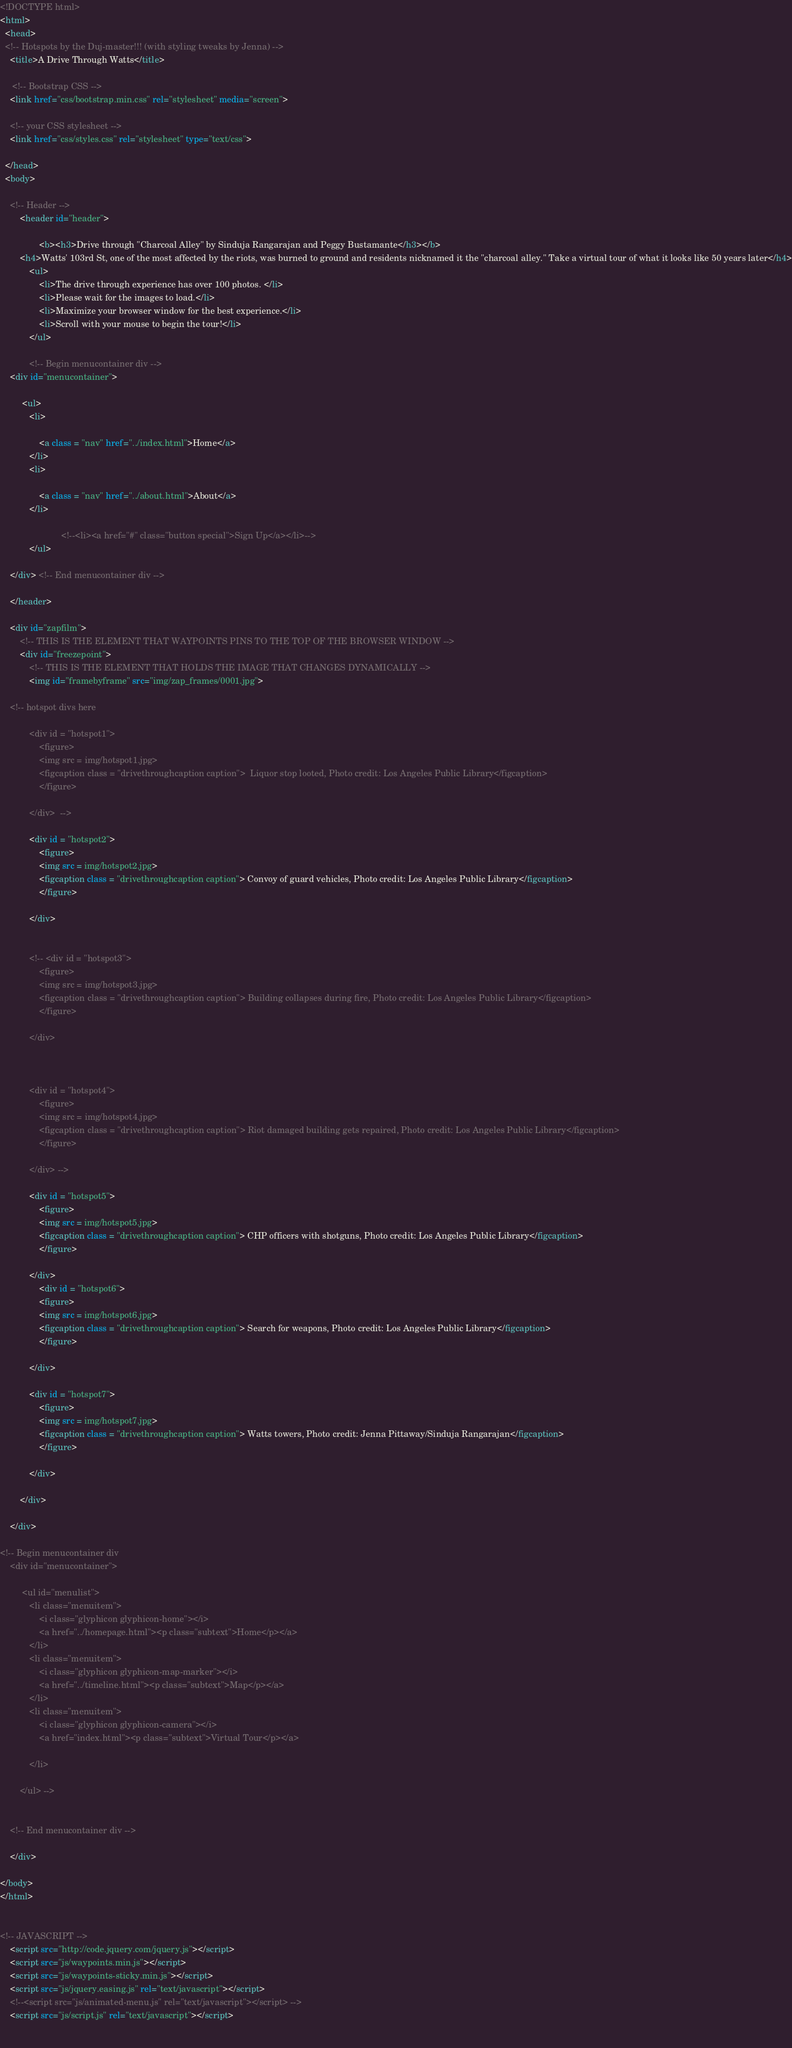<code> <loc_0><loc_0><loc_500><loc_500><_HTML_><!DOCTYPE html>
<html>
  <head>
  <!-- Hotspots by the Duj-master!!! (with styling tweaks by Jenna) -->
    <title>A Drive Through Watts</title>
    
     <!-- Bootstrap CSS -->
    <link href="css/bootstrap.min.css" rel="stylesheet" media="screen">

	<!-- your CSS stylesheet -->	
	<link href="css/styles.css" rel="stylesheet" type="text/css">
  
  </head>
  <body>

  	<!-- Header -->
		<header id="header">

				<b><h3>Drive through "Charcoal Alley" by Sinduja Rangarajan and Peggy Bustamante</h3></b>
		<h4>Watts' 103rd St, one of the most affected by the riots, was burned to ground and residents nicknamed it the "charcoal alley." Take a virtual tour of what it looks like 50 years later</h4>
			<ul>
				<li>The drive through experience has over 100 photos. </li>
				<li>Please wait for the images to load.</li> 
				<li>Maximize your browser window for the best experience.</li> 
				<li>Scroll with your mouse to begin the tour!</li>
			</ul>

			<!-- Begin menucontainer div -->
	<div id="menucontainer">
	
		 <ul>
			<li>
				
				<a class = "nav" href="../index.html">Home</a>
			</li>
			<li>
				
				<a class = "nav" href="../about.html">About</a>
			</li>
			
						 <!--<li><a href="#" class="button special">Sign Up</a></li>-->
			</ul> 

	</div> <!-- End menucontainer div -->	

	</header>
    
 	<div id="zapfilm">
		<!-- THIS IS THE ELEMENT THAT WAYPOINTS PINS TO THE TOP OF THE BROWSER WINDOW -->
		<div id="freezepoint">	
			<!-- THIS IS THE ELEMENT THAT HOLDS THE IMAGE THAT CHANGES DYNAMICALLY -->
			<img id="framebyframe" src="img/zap_frames/0001.jpg">	

	<!-- hotspot divs here 
						 
			<div id = "hotspot1">
				<figure>
				<img src = img/hotspot1.jpg>
				<figcaption class = "drivethroughcaption caption">  Liquor stop looted, Photo credit: Los Angeles Public Library</figcaption>
				</figure> 
		
			</div>	-->
		
			<div id = "hotspot2">
				<figure>
				<img src = img/hotspot2.jpg>
				<figcaption class = "drivethroughcaption caption"> Convoy of guard vehicles, Photo credit: Los Angeles Public Library</figcaption>
				</figure>
		
			</div>	
		
			
			<!-- <div id = "hotspot3">
				<figure>
				<img src = img/hotspot3.jpg>
				<figcaption class = "drivethroughcaption caption"> Building collapses during fire, Photo credit: Los Angeles Public Library</figcaption>
				</figure>
		
			</div>	
	
	
		
			<div id = "hotspot4">
				<figure>
				<img src = img/hotspot4.jpg>
				<figcaption class = "drivethroughcaption caption"> Riot damaged building gets repaired, Photo credit: Los Angeles Public Library</figcaption>
				</figure>
		
			</div> -->
		
			<div id = "hotspot5">
				<figure>
				<img src = img/hotspot5.jpg>
				<figcaption class = "drivethroughcaption caption"> CHP officers with shotguns, Photo credit: Los Angeles Public Library</figcaption>
				</figure>
		
			</div>
				<div id = "hotspot6">
				<figure>
				<img src = img/hotspot6.jpg>
				<figcaption class = "drivethroughcaption caption"> Search for weapons, Photo credit: Los Angeles Public Library</figcaption>
				</figure>
		
			</div>
		
			<div id = "hotspot7">
				<figure>
				<img src = img/hotspot7.jpg>
				<figcaption class = "drivethroughcaption caption"> Watts towers, Photo credit: Jenna Pittaway/Sinduja Rangarajan</figcaption>
				</figure>
		
			</div>
		
		</div>	
		
	</div>

<!-- Begin menucontainer div 
	<div id="menucontainer">
	
		 <ul id="menulist">
			<li class="menuitem">
				<i class="glyphicon glyphicon-home"></i>
				<a href="../homepage.html"><p class="subtext">Home</p></a>
			</li>
			<li class="menuitem">
				<i class="glyphicon glyphicon-map-marker"></i>
				<a href="../timeline.html"><p class="subtext">Map</p></a>
			</li>
			<li class="menuitem">
				<i class="glyphicon glyphicon-camera"></i>
				<a href="index.html"><p class="subtext">Virtual Tour</p></a>
				
			</li>
			
		</ul> -->


	<!-- End menucontainer div -->	

	</div> 
   	
</body>
</html>
				
				
<!-- JAVASCRIPT -->
	<script src="http://code.jquery.com/jquery.js"></script>
	<script src="js/waypoints.min.js"></script>
	<script src="js/waypoints-sticky.min.js"></script>
	<script src="js/jquery.easing.js" rel="text/javascript"></script>
	<!--<script src="js/animated-menu.js" rel="text/javascript"></script> -->
	<script src="js/script.js" rel="text/javascript"></script> 
	
	
</code> 